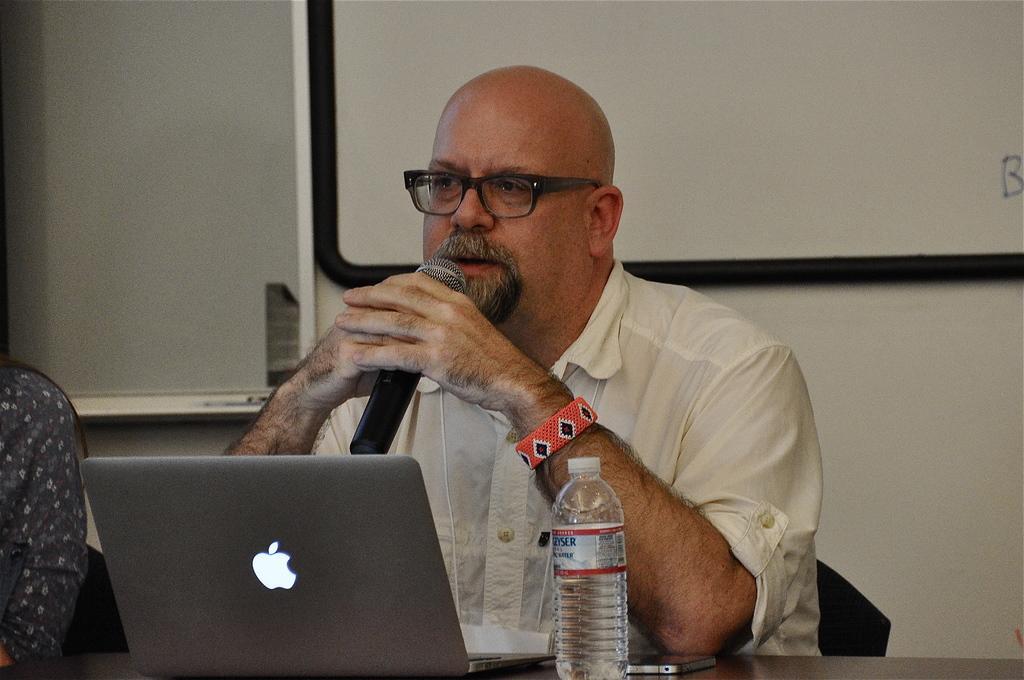How would you summarize this image in a sentence or two? there is a man sitting holding a microphone in his hand is speaking behind him there is a laptop water bottle and cell phone on the table. 